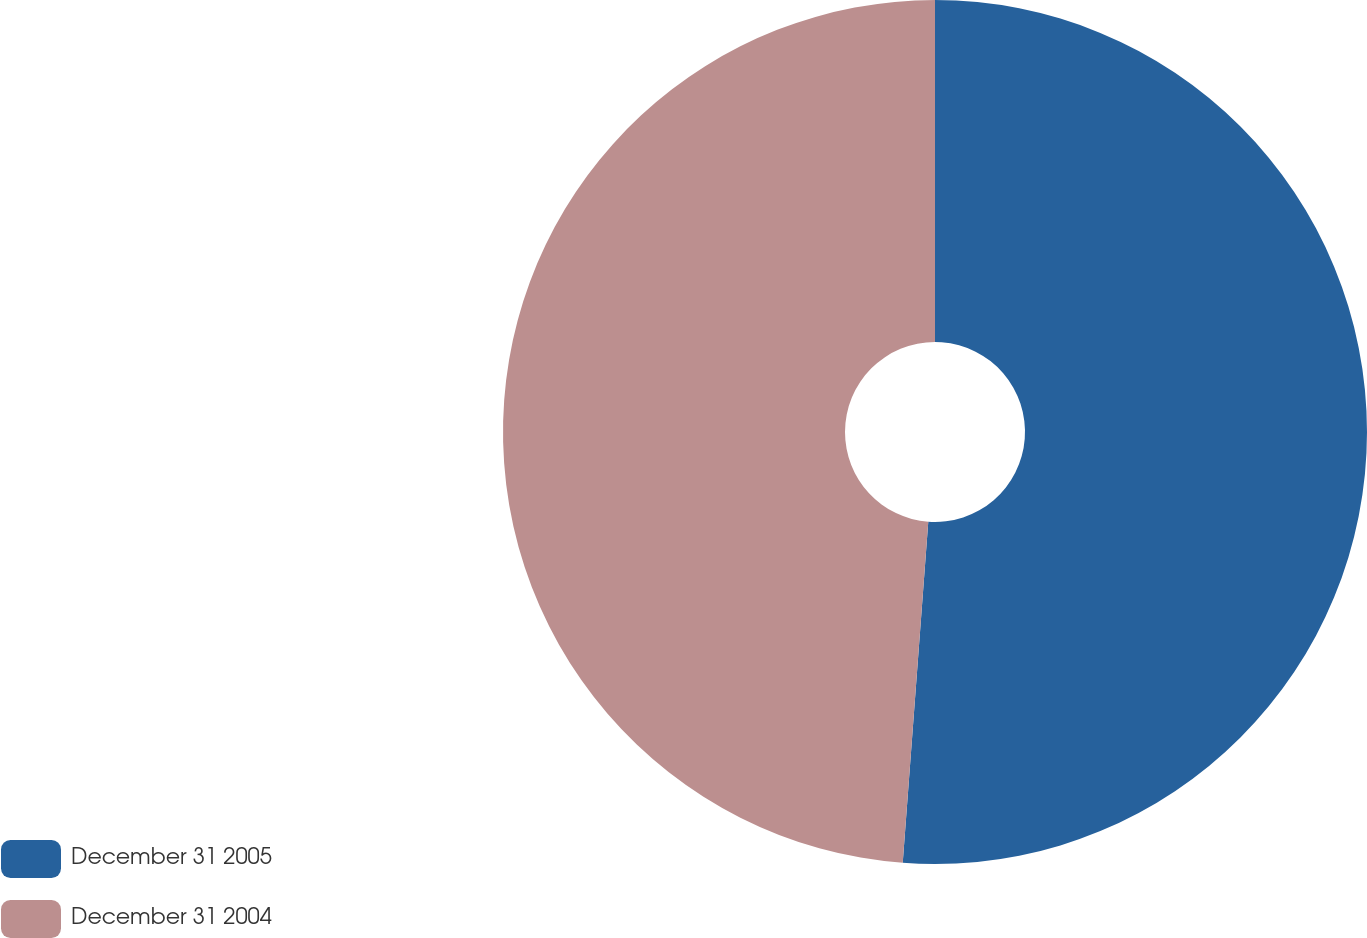<chart> <loc_0><loc_0><loc_500><loc_500><pie_chart><fcel>December 31 2005<fcel>December 31 2004<nl><fcel>51.19%<fcel>48.81%<nl></chart> 